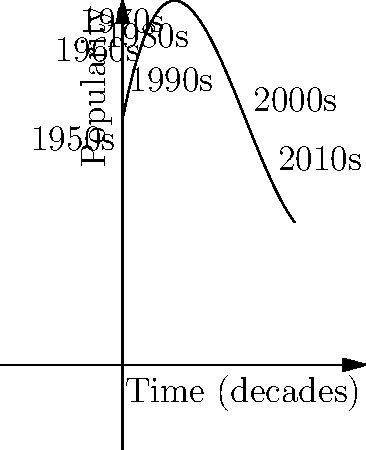The graph represents the popularity of jazz music over time, from the 1950s to the 2010s. Given that the function is a cubic polynomial, what is the decade when jazz popularity reached its minimum according to this model? To find the decade when jazz popularity reached its minimum, we need to follow these steps:

1. Observe that the graph is a cubic function, which means it has the form $f(x) = ax^3 + bx^2 + cx + d$.

2. The minimum point of a cubic function occurs at the local minimum, which is the lower turning point of the curve.

3. From the graph, we can see that the lowest point appears to be between the 1980s and 1990s.

4. To be more precise, we need to find where the derivative of the function equals zero. However, without the exact function, we can estimate based on the graph.

5. The graph shows the lowest point is closer to the 1990s label, which corresponds to $x = 4$ on our scale (where each unit represents a decade, starting from 0 for the 1950s).

6. Therefore, the minimum popularity occurs around the 1990s.
Answer: 1990s 